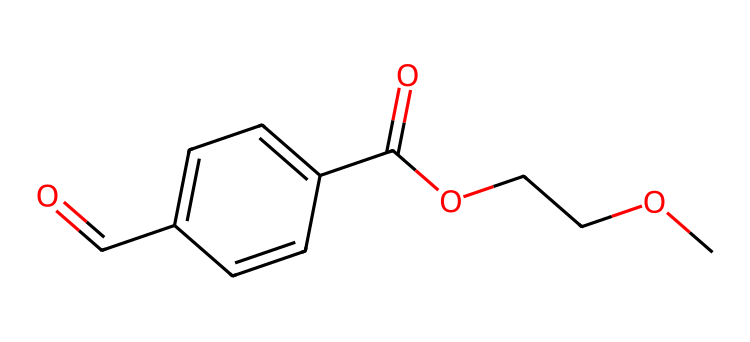What is the primary functional group present in this chemical? The chemical structure contains a carboxylic acid functional group (-COOH), which can be identified by the presence of the carbonyl (C=O) and hydroxyl (O-H) groups adjacent to each other.
Answer: carboxylic acid How many carbon atoms are present in this molecule? By analyzing the SMILES representation, we can count the carbon atoms indicated by "C" in the structure. The representation shows a total of 10 carbon atoms.
Answer: 10 What type of polymer does this chemical represent? This chemical corresponds to polyethylene terephthalate (PET), which is a common type of polyester used in plastics, especially in bottles.
Answer: polyester What is the total number of oxygen atoms in this chemical? In the provided SMILES, the oxygen atoms are represented by "O". Counting each occurrence in the structure reveals a total of 4 oxygen atoms present.
Answer: 4 How many double bonds are present in this molecule? Upon examining the structure, one can identify the presence of double bonds through the "=" symbol. The molecule includes 2 double bonds in total.
Answer: 2 What is the connectivity of the oxygen atoms in this molecular structure? The SMILES depicts that there are two carbonyl groups (C=O) and one ether group (OCCO), indicating the connectivity involves both ketone (C=O) and ether (-O-) linkages.
Answer: ketone and ether 